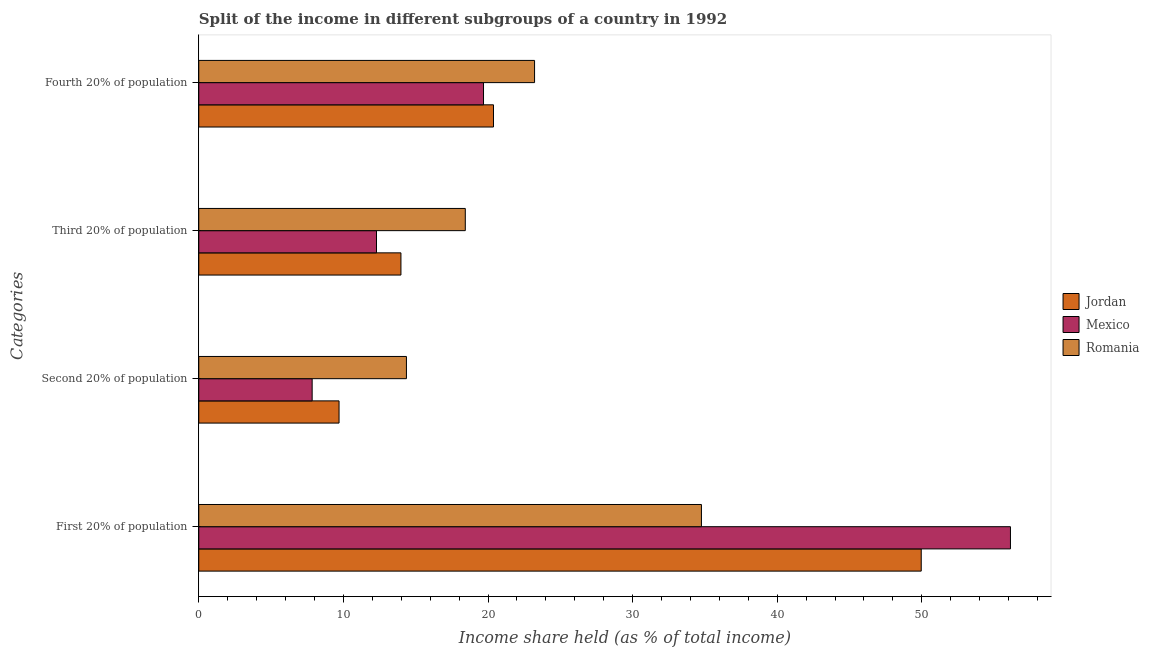How many different coloured bars are there?
Your answer should be very brief. 3. Are the number of bars on each tick of the Y-axis equal?
Your response must be concise. Yes. How many bars are there on the 4th tick from the top?
Offer a terse response. 3. How many bars are there on the 1st tick from the bottom?
Provide a short and direct response. 3. What is the label of the 3rd group of bars from the top?
Make the answer very short. Second 20% of population. What is the share of the income held by first 20% of the population in Romania?
Provide a succinct answer. 34.76. Across all countries, what is the maximum share of the income held by fourth 20% of the population?
Provide a short and direct response. 23.22. Across all countries, what is the minimum share of the income held by third 20% of the population?
Give a very brief answer. 12.29. In which country was the share of the income held by third 20% of the population maximum?
Give a very brief answer. Romania. What is the total share of the income held by first 20% of the population in the graph?
Make the answer very short. 140.85. What is the difference between the share of the income held by first 20% of the population in Mexico and that in Romania?
Provide a succinct answer. 21.37. What is the difference between the share of the income held by third 20% of the population in Jordan and the share of the income held by first 20% of the population in Mexico?
Keep it short and to the point. -42.15. What is the average share of the income held by fourth 20% of the population per country?
Your answer should be very brief. 21.1. What is the difference between the share of the income held by third 20% of the population and share of the income held by second 20% of the population in Romania?
Ensure brevity in your answer.  4.07. In how many countries, is the share of the income held by first 20% of the population greater than 14 %?
Your answer should be very brief. 3. What is the ratio of the share of the income held by third 20% of the population in Jordan to that in Mexico?
Your answer should be very brief. 1.14. Is the share of the income held by second 20% of the population in Jordan less than that in Mexico?
Give a very brief answer. No. Is the difference between the share of the income held by second 20% of the population in Jordan and Mexico greater than the difference between the share of the income held by third 20% of the population in Jordan and Mexico?
Provide a succinct answer. Yes. What is the difference between the highest and the second highest share of the income held by third 20% of the population?
Offer a very short reply. 4.45. What is the difference between the highest and the lowest share of the income held by third 20% of the population?
Your answer should be very brief. 6.14. What does the 1st bar from the bottom in Second 20% of population represents?
Offer a very short reply. Jordan. Is it the case that in every country, the sum of the share of the income held by first 20% of the population and share of the income held by second 20% of the population is greater than the share of the income held by third 20% of the population?
Offer a terse response. Yes. How many bars are there?
Keep it short and to the point. 12. Are all the bars in the graph horizontal?
Ensure brevity in your answer.  Yes. How many countries are there in the graph?
Your response must be concise. 3. Are the values on the major ticks of X-axis written in scientific E-notation?
Your response must be concise. No. Does the graph contain any zero values?
Provide a short and direct response. No. How many legend labels are there?
Provide a short and direct response. 3. What is the title of the graph?
Provide a succinct answer. Split of the income in different subgroups of a country in 1992. Does "Hong Kong" appear as one of the legend labels in the graph?
Provide a short and direct response. No. What is the label or title of the X-axis?
Keep it short and to the point. Income share held (as % of total income). What is the label or title of the Y-axis?
Keep it short and to the point. Categories. What is the Income share held (as % of total income) in Jordan in First 20% of population?
Your response must be concise. 49.96. What is the Income share held (as % of total income) of Mexico in First 20% of population?
Provide a short and direct response. 56.13. What is the Income share held (as % of total income) of Romania in First 20% of population?
Ensure brevity in your answer.  34.76. What is the Income share held (as % of total income) of Jordan in Second 20% of population?
Offer a terse response. 9.7. What is the Income share held (as % of total income) of Mexico in Second 20% of population?
Your answer should be compact. 7.84. What is the Income share held (as % of total income) of Romania in Second 20% of population?
Keep it short and to the point. 14.36. What is the Income share held (as % of total income) in Jordan in Third 20% of population?
Provide a short and direct response. 13.98. What is the Income share held (as % of total income) of Mexico in Third 20% of population?
Your response must be concise. 12.29. What is the Income share held (as % of total income) in Romania in Third 20% of population?
Offer a very short reply. 18.43. What is the Income share held (as % of total income) of Jordan in Fourth 20% of population?
Make the answer very short. 20.38. What is the Income share held (as % of total income) of Mexico in Fourth 20% of population?
Make the answer very short. 19.69. What is the Income share held (as % of total income) of Romania in Fourth 20% of population?
Keep it short and to the point. 23.22. Across all Categories, what is the maximum Income share held (as % of total income) in Jordan?
Offer a terse response. 49.96. Across all Categories, what is the maximum Income share held (as % of total income) in Mexico?
Offer a very short reply. 56.13. Across all Categories, what is the maximum Income share held (as % of total income) of Romania?
Your answer should be very brief. 34.76. Across all Categories, what is the minimum Income share held (as % of total income) in Jordan?
Make the answer very short. 9.7. Across all Categories, what is the minimum Income share held (as % of total income) of Mexico?
Your answer should be compact. 7.84. Across all Categories, what is the minimum Income share held (as % of total income) of Romania?
Your answer should be compact. 14.36. What is the total Income share held (as % of total income) in Jordan in the graph?
Provide a short and direct response. 94.02. What is the total Income share held (as % of total income) in Mexico in the graph?
Ensure brevity in your answer.  95.95. What is the total Income share held (as % of total income) of Romania in the graph?
Give a very brief answer. 90.77. What is the difference between the Income share held (as % of total income) in Jordan in First 20% of population and that in Second 20% of population?
Provide a succinct answer. 40.26. What is the difference between the Income share held (as % of total income) of Mexico in First 20% of population and that in Second 20% of population?
Provide a succinct answer. 48.29. What is the difference between the Income share held (as % of total income) of Romania in First 20% of population and that in Second 20% of population?
Your answer should be very brief. 20.4. What is the difference between the Income share held (as % of total income) of Jordan in First 20% of population and that in Third 20% of population?
Your response must be concise. 35.98. What is the difference between the Income share held (as % of total income) in Mexico in First 20% of population and that in Third 20% of population?
Provide a short and direct response. 43.84. What is the difference between the Income share held (as % of total income) of Romania in First 20% of population and that in Third 20% of population?
Keep it short and to the point. 16.33. What is the difference between the Income share held (as % of total income) in Jordan in First 20% of population and that in Fourth 20% of population?
Keep it short and to the point. 29.58. What is the difference between the Income share held (as % of total income) of Mexico in First 20% of population and that in Fourth 20% of population?
Offer a very short reply. 36.44. What is the difference between the Income share held (as % of total income) of Romania in First 20% of population and that in Fourth 20% of population?
Ensure brevity in your answer.  11.54. What is the difference between the Income share held (as % of total income) in Jordan in Second 20% of population and that in Third 20% of population?
Offer a terse response. -4.28. What is the difference between the Income share held (as % of total income) in Mexico in Second 20% of population and that in Third 20% of population?
Make the answer very short. -4.45. What is the difference between the Income share held (as % of total income) in Romania in Second 20% of population and that in Third 20% of population?
Make the answer very short. -4.07. What is the difference between the Income share held (as % of total income) in Jordan in Second 20% of population and that in Fourth 20% of population?
Your answer should be compact. -10.68. What is the difference between the Income share held (as % of total income) of Mexico in Second 20% of population and that in Fourth 20% of population?
Your answer should be very brief. -11.85. What is the difference between the Income share held (as % of total income) in Romania in Second 20% of population and that in Fourth 20% of population?
Ensure brevity in your answer.  -8.86. What is the difference between the Income share held (as % of total income) of Jordan in Third 20% of population and that in Fourth 20% of population?
Provide a short and direct response. -6.4. What is the difference between the Income share held (as % of total income) in Mexico in Third 20% of population and that in Fourth 20% of population?
Ensure brevity in your answer.  -7.4. What is the difference between the Income share held (as % of total income) in Romania in Third 20% of population and that in Fourth 20% of population?
Offer a very short reply. -4.79. What is the difference between the Income share held (as % of total income) in Jordan in First 20% of population and the Income share held (as % of total income) in Mexico in Second 20% of population?
Ensure brevity in your answer.  42.12. What is the difference between the Income share held (as % of total income) of Jordan in First 20% of population and the Income share held (as % of total income) of Romania in Second 20% of population?
Give a very brief answer. 35.6. What is the difference between the Income share held (as % of total income) of Mexico in First 20% of population and the Income share held (as % of total income) of Romania in Second 20% of population?
Ensure brevity in your answer.  41.77. What is the difference between the Income share held (as % of total income) of Jordan in First 20% of population and the Income share held (as % of total income) of Mexico in Third 20% of population?
Your answer should be compact. 37.67. What is the difference between the Income share held (as % of total income) of Jordan in First 20% of population and the Income share held (as % of total income) of Romania in Third 20% of population?
Offer a very short reply. 31.53. What is the difference between the Income share held (as % of total income) of Mexico in First 20% of population and the Income share held (as % of total income) of Romania in Third 20% of population?
Provide a short and direct response. 37.7. What is the difference between the Income share held (as % of total income) of Jordan in First 20% of population and the Income share held (as % of total income) of Mexico in Fourth 20% of population?
Ensure brevity in your answer.  30.27. What is the difference between the Income share held (as % of total income) in Jordan in First 20% of population and the Income share held (as % of total income) in Romania in Fourth 20% of population?
Your answer should be very brief. 26.74. What is the difference between the Income share held (as % of total income) in Mexico in First 20% of population and the Income share held (as % of total income) in Romania in Fourth 20% of population?
Provide a succinct answer. 32.91. What is the difference between the Income share held (as % of total income) of Jordan in Second 20% of population and the Income share held (as % of total income) of Mexico in Third 20% of population?
Keep it short and to the point. -2.59. What is the difference between the Income share held (as % of total income) of Jordan in Second 20% of population and the Income share held (as % of total income) of Romania in Third 20% of population?
Your response must be concise. -8.73. What is the difference between the Income share held (as % of total income) in Mexico in Second 20% of population and the Income share held (as % of total income) in Romania in Third 20% of population?
Your answer should be compact. -10.59. What is the difference between the Income share held (as % of total income) in Jordan in Second 20% of population and the Income share held (as % of total income) in Mexico in Fourth 20% of population?
Make the answer very short. -9.99. What is the difference between the Income share held (as % of total income) of Jordan in Second 20% of population and the Income share held (as % of total income) of Romania in Fourth 20% of population?
Your answer should be compact. -13.52. What is the difference between the Income share held (as % of total income) in Mexico in Second 20% of population and the Income share held (as % of total income) in Romania in Fourth 20% of population?
Offer a very short reply. -15.38. What is the difference between the Income share held (as % of total income) of Jordan in Third 20% of population and the Income share held (as % of total income) of Mexico in Fourth 20% of population?
Your answer should be very brief. -5.71. What is the difference between the Income share held (as % of total income) of Jordan in Third 20% of population and the Income share held (as % of total income) of Romania in Fourth 20% of population?
Your response must be concise. -9.24. What is the difference between the Income share held (as % of total income) of Mexico in Third 20% of population and the Income share held (as % of total income) of Romania in Fourth 20% of population?
Give a very brief answer. -10.93. What is the average Income share held (as % of total income) in Jordan per Categories?
Your answer should be compact. 23.5. What is the average Income share held (as % of total income) in Mexico per Categories?
Ensure brevity in your answer.  23.99. What is the average Income share held (as % of total income) of Romania per Categories?
Offer a terse response. 22.69. What is the difference between the Income share held (as % of total income) of Jordan and Income share held (as % of total income) of Mexico in First 20% of population?
Offer a terse response. -6.17. What is the difference between the Income share held (as % of total income) of Jordan and Income share held (as % of total income) of Romania in First 20% of population?
Your response must be concise. 15.2. What is the difference between the Income share held (as % of total income) of Mexico and Income share held (as % of total income) of Romania in First 20% of population?
Your response must be concise. 21.37. What is the difference between the Income share held (as % of total income) of Jordan and Income share held (as % of total income) of Mexico in Second 20% of population?
Provide a short and direct response. 1.86. What is the difference between the Income share held (as % of total income) of Jordan and Income share held (as % of total income) of Romania in Second 20% of population?
Give a very brief answer. -4.66. What is the difference between the Income share held (as % of total income) in Mexico and Income share held (as % of total income) in Romania in Second 20% of population?
Ensure brevity in your answer.  -6.52. What is the difference between the Income share held (as % of total income) in Jordan and Income share held (as % of total income) in Mexico in Third 20% of population?
Offer a terse response. 1.69. What is the difference between the Income share held (as % of total income) of Jordan and Income share held (as % of total income) of Romania in Third 20% of population?
Offer a terse response. -4.45. What is the difference between the Income share held (as % of total income) in Mexico and Income share held (as % of total income) in Romania in Third 20% of population?
Give a very brief answer. -6.14. What is the difference between the Income share held (as % of total income) of Jordan and Income share held (as % of total income) of Mexico in Fourth 20% of population?
Your response must be concise. 0.69. What is the difference between the Income share held (as % of total income) of Jordan and Income share held (as % of total income) of Romania in Fourth 20% of population?
Offer a very short reply. -2.84. What is the difference between the Income share held (as % of total income) in Mexico and Income share held (as % of total income) in Romania in Fourth 20% of population?
Keep it short and to the point. -3.53. What is the ratio of the Income share held (as % of total income) in Jordan in First 20% of population to that in Second 20% of population?
Provide a short and direct response. 5.15. What is the ratio of the Income share held (as % of total income) of Mexico in First 20% of population to that in Second 20% of population?
Give a very brief answer. 7.16. What is the ratio of the Income share held (as % of total income) of Romania in First 20% of population to that in Second 20% of population?
Your answer should be compact. 2.42. What is the ratio of the Income share held (as % of total income) in Jordan in First 20% of population to that in Third 20% of population?
Make the answer very short. 3.57. What is the ratio of the Income share held (as % of total income) in Mexico in First 20% of population to that in Third 20% of population?
Keep it short and to the point. 4.57. What is the ratio of the Income share held (as % of total income) in Romania in First 20% of population to that in Third 20% of population?
Offer a very short reply. 1.89. What is the ratio of the Income share held (as % of total income) of Jordan in First 20% of population to that in Fourth 20% of population?
Offer a very short reply. 2.45. What is the ratio of the Income share held (as % of total income) of Mexico in First 20% of population to that in Fourth 20% of population?
Offer a very short reply. 2.85. What is the ratio of the Income share held (as % of total income) in Romania in First 20% of population to that in Fourth 20% of population?
Ensure brevity in your answer.  1.5. What is the ratio of the Income share held (as % of total income) in Jordan in Second 20% of population to that in Third 20% of population?
Offer a terse response. 0.69. What is the ratio of the Income share held (as % of total income) in Mexico in Second 20% of population to that in Third 20% of population?
Offer a very short reply. 0.64. What is the ratio of the Income share held (as % of total income) of Romania in Second 20% of population to that in Third 20% of population?
Provide a succinct answer. 0.78. What is the ratio of the Income share held (as % of total income) in Jordan in Second 20% of population to that in Fourth 20% of population?
Offer a terse response. 0.48. What is the ratio of the Income share held (as % of total income) in Mexico in Second 20% of population to that in Fourth 20% of population?
Keep it short and to the point. 0.4. What is the ratio of the Income share held (as % of total income) in Romania in Second 20% of population to that in Fourth 20% of population?
Your answer should be very brief. 0.62. What is the ratio of the Income share held (as % of total income) in Jordan in Third 20% of population to that in Fourth 20% of population?
Keep it short and to the point. 0.69. What is the ratio of the Income share held (as % of total income) in Mexico in Third 20% of population to that in Fourth 20% of population?
Offer a very short reply. 0.62. What is the ratio of the Income share held (as % of total income) in Romania in Third 20% of population to that in Fourth 20% of population?
Provide a succinct answer. 0.79. What is the difference between the highest and the second highest Income share held (as % of total income) in Jordan?
Your answer should be compact. 29.58. What is the difference between the highest and the second highest Income share held (as % of total income) in Mexico?
Provide a short and direct response. 36.44. What is the difference between the highest and the second highest Income share held (as % of total income) of Romania?
Keep it short and to the point. 11.54. What is the difference between the highest and the lowest Income share held (as % of total income) of Jordan?
Your answer should be very brief. 40.26. What is the difference between the highest and the lowest Income share held (as % of total income) of Mexico?
Keep it short and to the point. 48.29. What is the difference between the highest and the lowest Income share held (as % of total income) of Romania?
Give a very brief answer. 20.4. 